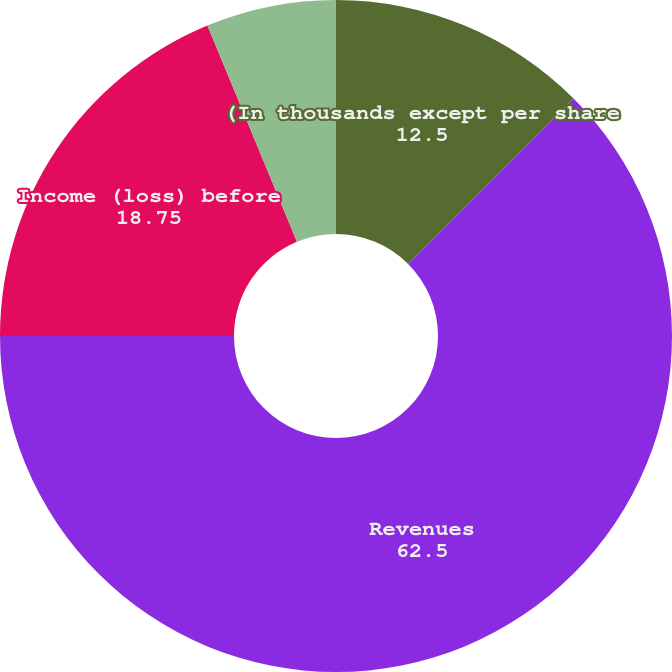Convert chart. <chart><loc_0><loc_0><loc_500><loc_500><pie_chart><fcel>(In thousands except per share<fcel>Revenues<fcel>Income (loss) before<fcel>Basic earnings (loss)<fcel>Diluted earnings (loss)<nl><fcel>12.5%<fcel>62.5%<fcel>18.75%<fcel>6.25%<fcel>0.0%<nl></chart> 